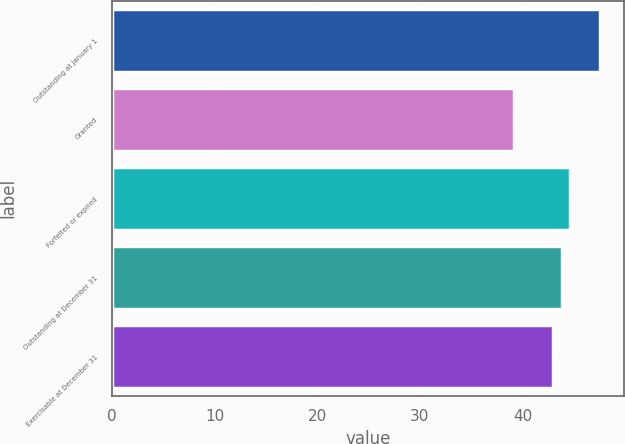Convert chart. <chart><loc_0><loc_0><loc_500><loc_500><bar_chart><fcel>Outstanding at January 1<fcel>Granted<fcel>Forfeited or expired<fcel>Outstanding at December 31<fcel>Exercisable at December 31<nl><fcel>47.51<fcel>39.18<fcel>44.65<fcel>43.82<fcel>42.99<nl></chart> 